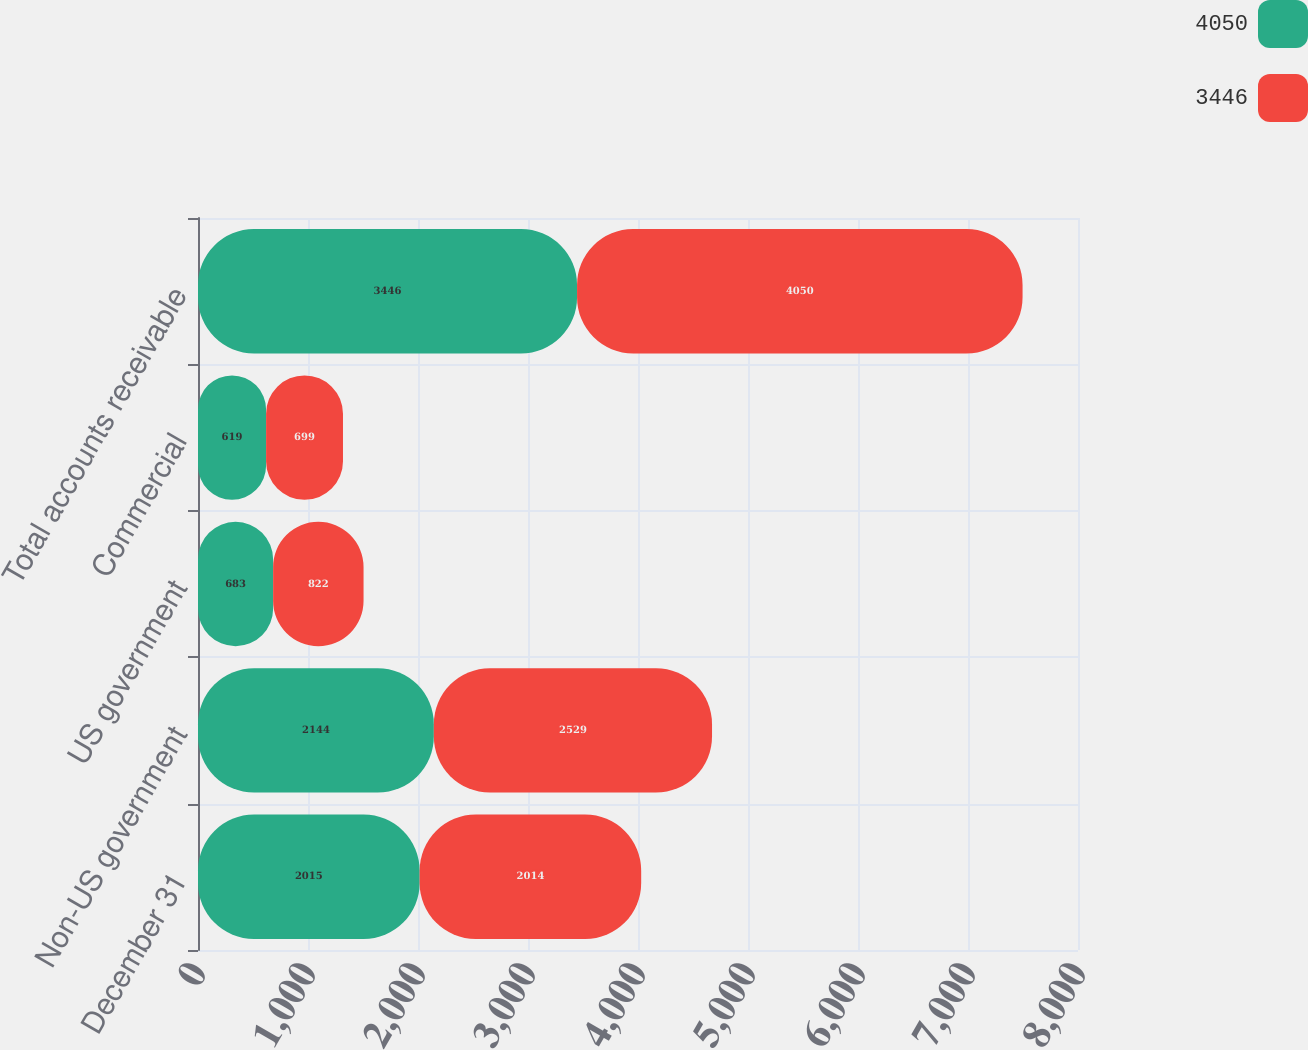Convert chart. <chart><loc_0><loc_0><loc_500><loc_500><stacked_bar_chart><ecel><fcel>December 31<fcel>Non-US government<fcel>US government<fcel>Commercial<fcel>Total accounts receivable<nl><fcel>4050<fcel>2015<fcel>2144<fcel>683<fcel>619<fcel>3446<nl><fcel>3446<fcel>2014<fcel>2529<fcel>822<fcel>699<fcel>4050<nl></chart> 